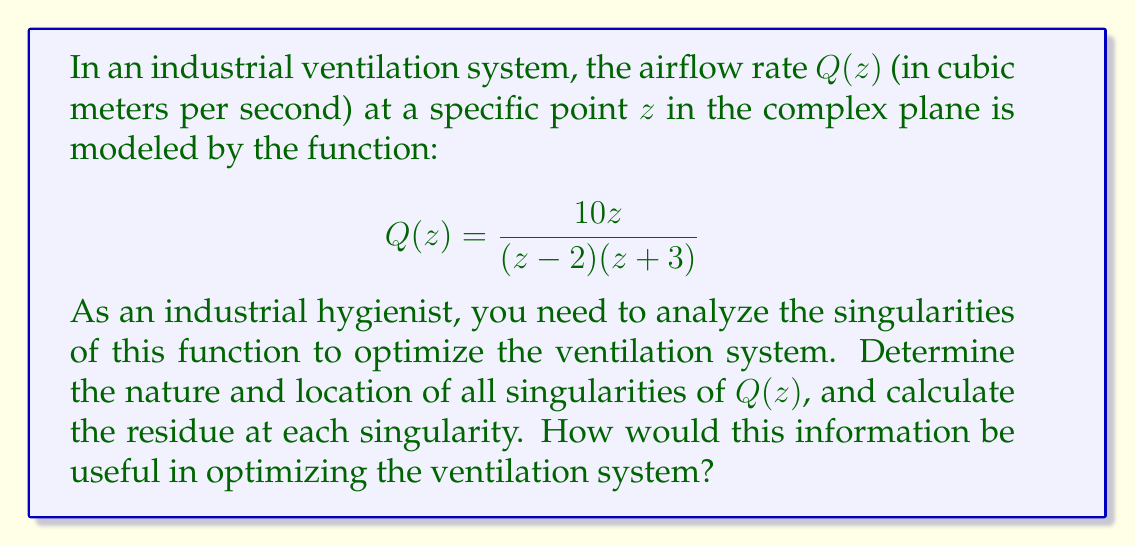Teach me how to tackle this problem. To analyze the singularities of the given function, we'll follow these steps:

1) Identify the singularities:
   The singularities occur where the denominator of the function equals zero:
   $(z-2)(z+3) = 0$
   This gives us two singularities: $z = 2$ and $z = -3$

2) Determine the nature of the singularities:
   Both singularities are simple poles because the numerator is not zero at these points, and the denominator has a factor of $(z-a)$ to the first power.

3) Calculate the residues:
   For a simple pole at $z = a$, the residue is given by:
   $$\text{Res}(Q, a) = \lim_{z \to a} (z-a)Q(z)$$

   For $z = 2$:
   $$\begin{align}
   \text{Res}(Q, 2) &= \lim_{z \to 2} (z-2)\frac{10z}{(z-2)(z+3)} \\
   &= \lim_{z \to 2} \frac{10z}{z+3} \\
   &= \frac{10(2)}{2+3} = 4
   \end{align}$$

   For $z = -3$:
   $$\begin{align}
   \text{Res}(Q, -3) &= \lim_{z \to -3} (z+3)\frac{10z}{(z-2)(z+3)} \\
   &= \lim_{z \to -3} \frac{10z}{z-2} \\
   &= \frac{10(-3)}{-3-2} = 6
   \end{align}$$

4) Interpretation for ventilation system optimization:
   The singularities represent critical points in the ventilation system where airflow behavior changes dramatically. The residues provide information about the strength and direction of airflow near these points.

   - The positive residue at $z = 2$ indicates a source-like behavior, where air is being introduced into the system.
   - The positive residue at $z = -3$ also indicates a source-like behavior, but with a stronger effect than at $z = 2$.

   This information can be used to:
   a) Identify potential areas of air stagnation or turbulence.
   b) Optimize placement of air inlets and outlets.
   c) Adjust fan speeds or duct sizes to balance airflow throughout the system.
   d) Ensure proper air exchange in all areas of the industrial space.

By understanding these critical points, an industrial hygienist can make informed decisions to improve air quality, worker safety, and energy efficiency in the ventilation system.
Answer: The function $Q(z) = \frac{10z}{(z-2)(z+3)}$ has two simple poles:
1) At $z = 2$ with residue 4
2) At $z = -3$ with residue 6

These singularities represent critical points in the ventilation system where airflow behavior changes significantly. The residues indicate source-like behavior at both points, with a stronger effect at $z = -3$. This information can be used to optimize air inlet/outlet placement, adjust fan speeds, and ensure proper air exchange throughout the industrial space. 